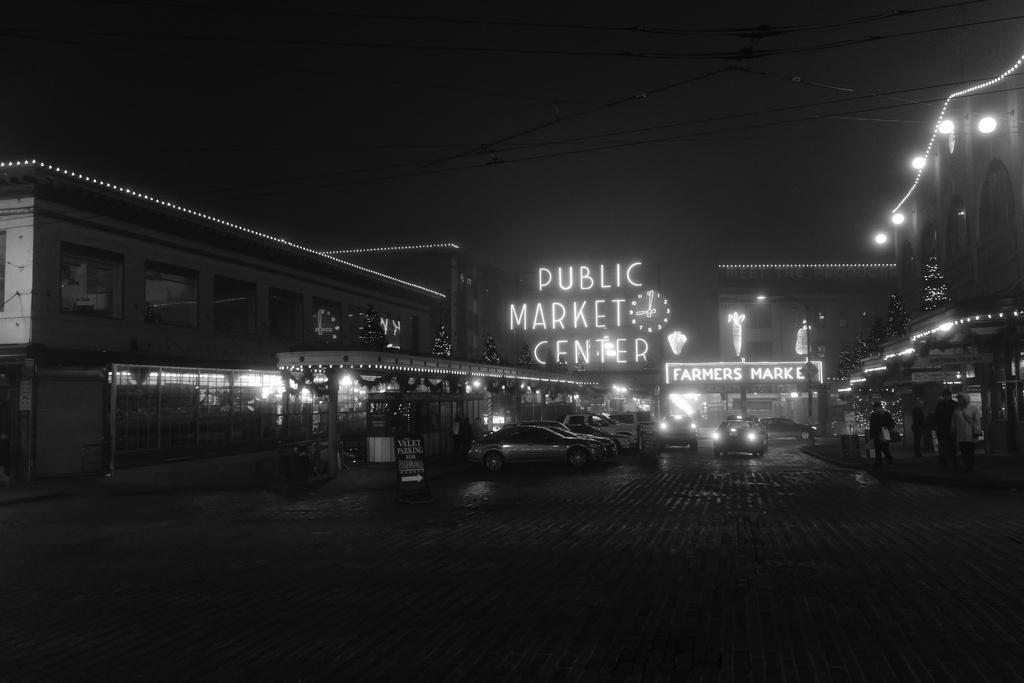Could you give a brief overview of what you see in this image? In this image in the middle, there are cars, buildings, road, text, lightnings and trees. The background is dark. 